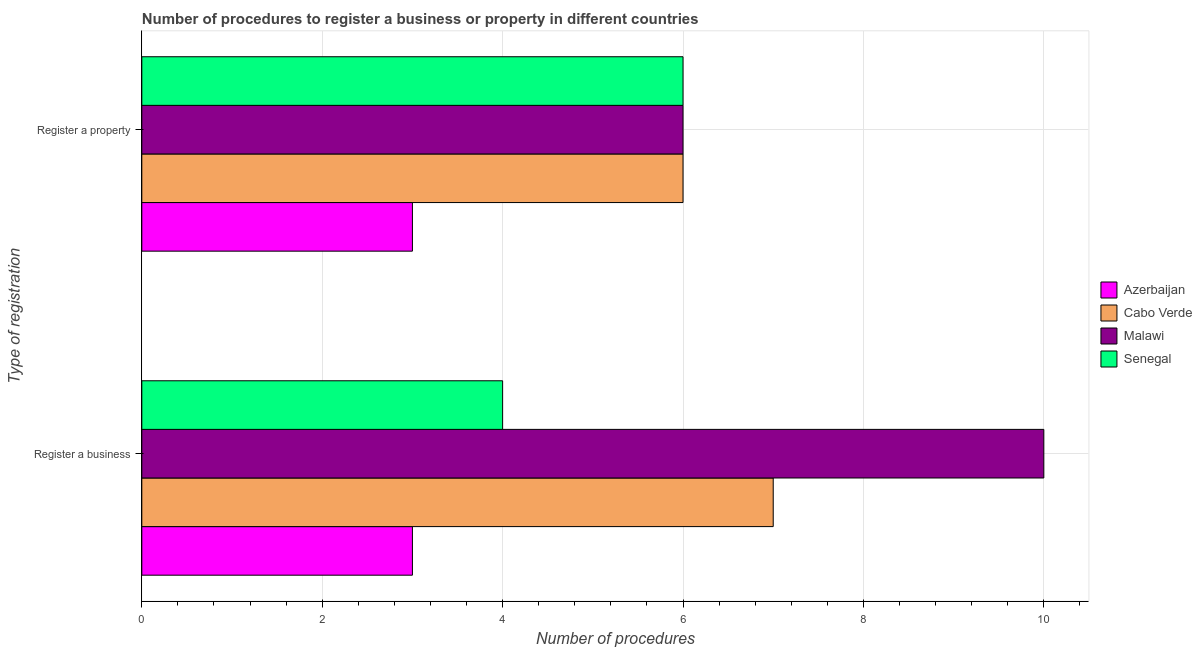How many different coloured bars are there?
Give a very brief answer. 4. How many groups of bars are there?
Your answer should be compact. 2. Are the number of bars on each tick of the Y-axis equal?
Your answer should be compact. Yes. What is the label of the 1st group of bars from the top?
Provide a short and direct response. Register a property. Across all countries, what is the maximum number of procedures to register a property?
Offer a very short reply. 6. Across all countries, what is the minimum number of procedures to register a business?
Make the answer very short. 3. In which country was the number of procedures to register a business maximum?
Ensure brevity in your answer.  Malawi. In which country was the number of procedures to register a business minimum?
Ensure brevity in your answer.  Azerbaijan. What is the total number of procedures to register a business in the graph?
Offer a very short reply. 24. What is the difference between the number of procedures to register a property in Senegal and that in Azerbaijan?
Provide a short and direct response. 3. What is the difference between the number of procedures to register a business in Cabo Verde and the number of procedures to register a property in Azerbaijan?
Provide a succinct answer. 4. What is the average number of procedures to register a property per country?
Your answer should be very brief. 5.25. What is the difference between the number of procedures to register a business and number of procedures to register a property in Senegal?
Offer a very short reply. -2. In how many countries, is the number of procedures to register a property greater than 4 ?
Provide a short and direct response. 3. What is the ratio of the number of procedures to register a property in Cabo Verde to that in Senegal?
Your answer should be very brief. 1. Is the number of procedures to register a property in Malawi less than that in Cabo Verde?
Ensure brevity in your answer.  No. In how many countries, is the number of procedures to register a property greater than the average number of procedures to register a property taken over all countries?
Your answer should be compact. 3. What does the 2nd bar from the top in Register a property represents?
Your answer should be very brief. Malawi. What does the 1st bar from the bottom in Register a property represents?
Ensure brevity in your answer.  Azerbaijan. Are all the bars in the graph horizontal?
Keep it short and to the point. Yes. How many countries are there in the graph?
Your answer should be compact. 4. What is the difference between two consecutive major ticks on the X-axis?
Your answer should be compact. 2. Are the values on the major ticks of X-axis written in scientific E-notation?
Make the answer very short. No. Does the graph contain any zero values?
Give a very brief answer. No. Does the graph contain grids?
Keep it short and to the point. Yes. Where does the legend appear in the graph?
Provide a succinct answer. Center right. How are the legend labels stacked?
Make the answer very short. Vertical. What is the title of the graph?
Your answer should be compact. Number of procedures to register a business or property in different countries. What is the label or title of the X-axis?
Provide a succinct answer. Number of procedures. What is the label or title of the Y-axis?
Keep it short and to the point. Type of registration. What is the Number of procedures in Azerbaijan in Register a business?
Give a very brief answer. 3. What is the Number of procedures of Cabo Verde in Register a business?
Provide a short and direct response. 7. What is the Number of procedures in Senegal in Register a business?
Offer a very short reply. 4. What is the Number of procedures in Malawi in Register a property?
Your response must be concise. 6. What is the Number of procedures of Senegal in Register a property?
Your answer should be very brief. 6. Across all Type of registration, what is the maximum Number of procedures of Azerbaijan?
Keep it short and to the point. 3. Across all Type of registration, what is the maximum Number of procedures of Cabo Verde?
Provide a short and direct response. 7. Across all Type of registration, what is the maximum Number of procedures in Malawi?
Keep it short and to the point. 10. Across all Type of registration, what is the maximum Number of procedures in Senegal?
Offer a very short reply. 6. What is the total Number of procedures of Azerbaijan in the graph?
Your response must be concise. 6. What is the total Number of procedures in Cabo Verde in the graph?
Offer a very short reply. 13. What is the difference between the Number of procedures of Azerbaijan in Register a business and that in Register a property?
Provide a succinct answer. 0. What is the difference between the Number of procedures in Cabo Verde in Register a business and that in Register a property?
Your response must be concise. 1. What is the difference between the Number of procedures of Senegal in Register a business and that in Register a property?
Make the answer very short. -2. What is the difference between the Number of procedures in Azerbaijan in Register a business and the Number of procedures in Cabo Verde in Register a property?
Give a very brief answer. -3. What is the difference between the Number of procedures in Azerbaijan in Register a business and the Number of procedures in Senegal in Register a property?
Make the answer very short. -3. What is the difference between the Number of procedures in Cabo Verde in Register a business and the Number of procedures in Malawi in Register a property?
Provide a short and direct response. 1. What is the difference between the Number of procedures in Malawi in Register a business and the Number of procedures in Senegal in Register a property?
Provide a short and direct response. 4. What is the average Number of procedures of Cabo Verde per Type of registration?
Offer a very short reply. 6.5. What is the average Number of procedures of Malawi per Type of registration?
Offer a terse response. 8. What is the difference between the Number of procedures of Azerbaijan and Number of procedures of Cabo Verde in Register a business?
Provide a short and direct response. -4. What is the difference between the Number of procedures of Azerbaijan and Number of procedures of Malawi in Register a business?
Ensure brevity in your answer.  -7. What is the difference between the Number of procedures in Azerbaijan and Number of procedures in Senegal in Register a business?
Provide a succinct answer. -1. What is the difference between the Number of procedures in Cabo Verde and Number of procedures in Malawi in Register a business?
Your answer should be very brief. -3. What is the difference between the Number of procedures in Malawi and Number of procedures in Senegal in Register a business?
Ensure brevity in your answer.  6. What is the difference between the Number of procedures in Azerbaijan and Number of procedures in Malawi in Register a property?
Your answer should be very brief. -3. What is the difference between the Number of procedures in Azerbaijan and Number of procedures in Senegal in Register a property?
Give a very brief answer. -3. What is the difference between the Number of procedures of Cabo Verde and Number of procedures of Malawi in Register a property?
Keep it short and to the point. 0. What is the difference between the Number of procedures of Cabo Verde and Number of procedures of Senegal in Register a property?
Make the answer very short. 0. What is the ratio of the Number of procedures of Cabo Verde in Register a business to that in Register a property?
Offer a terse response. 1.17. What is the ratio of the Number of procedures of Malawi in Register a business to that in Register a property?
Give a very brief answer. 1.67. What is the ratio of the Number of procedures of Senegal in Register a business to that in Register a property?
Your answer should be very brief. 0.67. What is the difference between the highest and the second highest Number of procedures of Azerbaijan?
Your response must be concise. 0. What is the difference between the highest and the second highest Number of procedures in Cabo Verde?
Provide a short and direct response. 1. What is the difference between the highest and the second highest Number of procedures of Malawi?
Keep it short and to the point. 4. What is the difference between the highest and the second highest Number of procedures of Senegal?
Your answer should be compact. 2. What is the difference between the highest and the lowest Number of procedures in Cabo Verde?
Offer a very short reply. 1. 